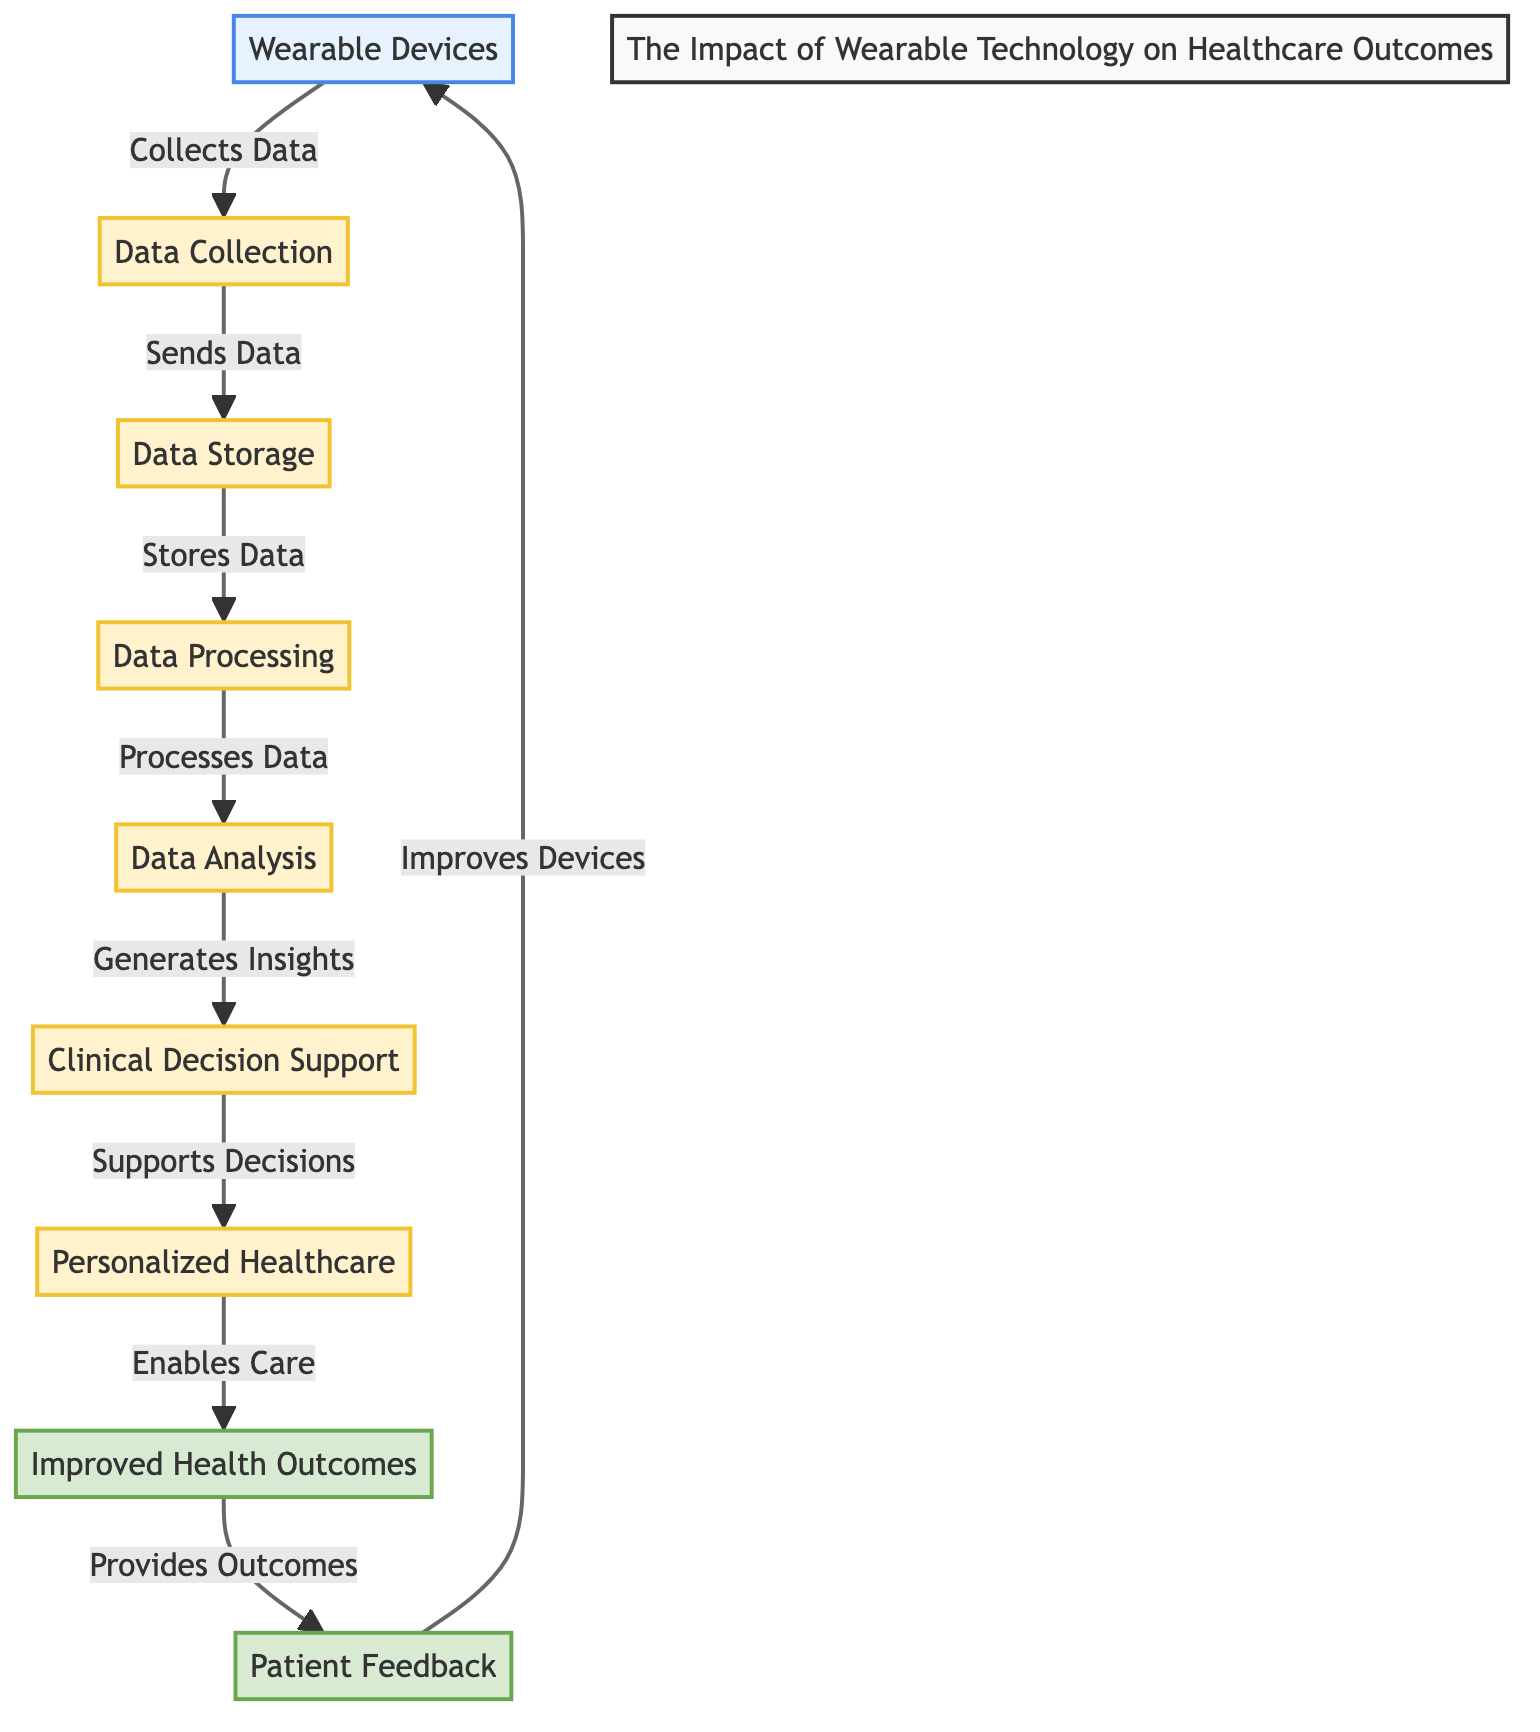What is the first step in the pathway? The first step in the pathway is the "Wearable Devices" which collects data. This node is the starting point of the entire flowchart.
Answer: Wearable Devices How many processes are outlined in the diagram? The diagram outlines six processes, which are: Data Collection, Data Storage, Data Processing, Data Analysis, Clinical Decision Support, and Personalized Healthcare.
Answer: Six What does the "Data Analysis" step generate? The "Data Analysis" step generates insights which are used in the following step of Clinical Decision Support. This indicates the outcome of the data analysis process.
Answer: Insights Which node provides feedback to improve devices? The node that provides feedback to improve devices is "Patient Feedback," which indicates how patient experiences can influence future developments in wearable technology.
Answer: Patient Feedback What follows after "Clinical Decision Support"? After "Clinical Decision Support," the next step is "Personalized Healthcare," indicating that the insights generated in the previous step support tailored healthcare decisions.
Answer: Personalized Healthcare What type of outcomes are improved as a result of this pathway? The type of outcomes that are improved as a result of this pathway is "Improved Health Outcomes," which signifies the ultimate goal of integrating wearable technology in healthcare.
Answer: Improved Health Outcomes In total, how many nodes are shown in the flowchart? The flowchart contains eight nodes in total, which include wearable devices, data collection, data storage, data processing, data analysis, clinical decision support, personalized healthcare, health outcomes, and patient feedback.
Answer: Eight Which process supports decision making in healthcare? The process that supports decision making in healthcare is "Clinical Decision Support," which relies on the insights generated through data analysis to aid clinical practitioners.
Answer: Clinical Decision Support What is the relationship between "Health Outcomes" and "Patient Feedback"? The relationship between "Health Outcomes" and "Patient Feedback" is that the improved health outcomes provide outcomes which are used to gather patient feedback, creating a loop that influences further enhancements in wearable technology.
Answer: Loop 